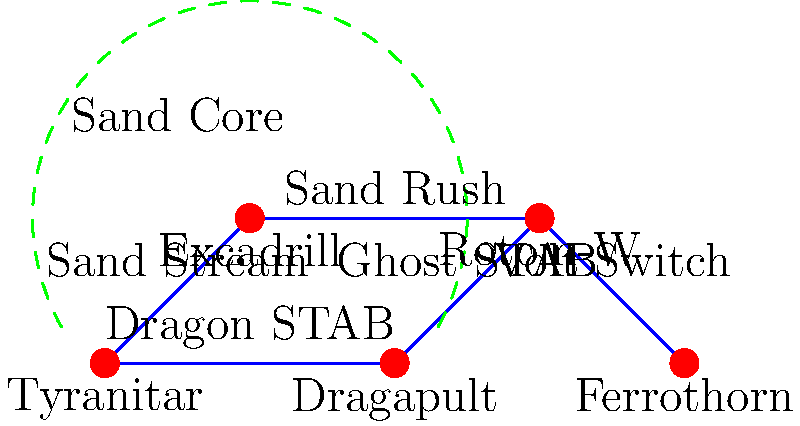In the given hypergraph representation of a competitive Pokémon team, which Pokémon serves as the central pivot for the team's strategy, and what key ability does it possess that synergizes with two other team members? To answer this question, we need to analyze the hypergraph and identify the key relationships between the Pokémon:

1. First, notice the dashed green arc connecting Tyranitar, Excadrill, and Rotom-W. This hyperedge is labeled "Sand Core," indicating a strategic synergy between these three Pokémon.

2. Tyranitar is connected to Excadrill with the edge labeled "Sand Stream." This suggests that Tyranitar has the ability Sand Stream, which automatically sets up a sandstorm when it enters battle.

3. Excadrill is connected to Rotom-W with the edge labeled "Sand Rush." This indicates that Excadrill has the ability Sand Rush, which doubles its speed in a sandstorm.

4. Rotom-W serves as a connector between the sand core and the rest of the team, with connections to both Dragapult and Ferrothorn.

5. The central position of Rotom-W in the graph, along with its multiple connections, suggests that it serves as the pivot for the team's strategy.

6. Rotom-W's connection to Ferrothorn is labeled "Volt Switch," which is a move that allows it to switch out after attacking, potentially bringing in Tyranitar or Excadrill to take advantage of the sandstorm.

Therefore, Rotom-W is the central pivot for the team's strategy. Its key move, Volt Switch, allows it to synergize with Tyranitar (by potentially bringing it in to set up sandstorm) and Excadrill (by potentially bringing it in to take advantage of Sand Rush in the sandstorm).
Answer: Rotom-W; Volt Switch 